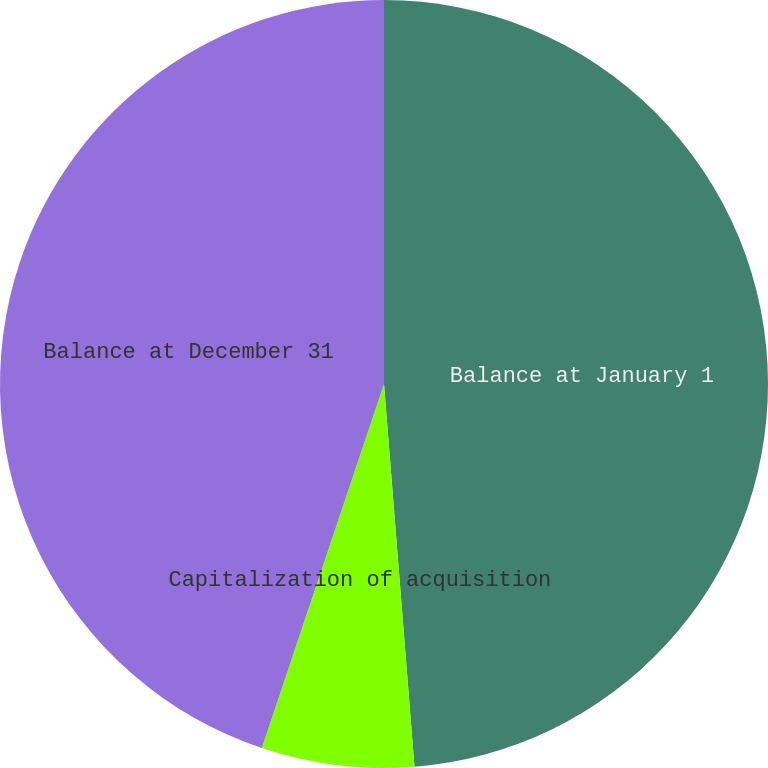<chart> <loc_0><loc_0><loc_500><loc_500><pie_chart><fcel>Balance at January 1<fcel>Capitalization of acquisition<fcel>Balance at December 31<nl><fcel>48.74%<fcel>6.42%<fcel>44.85%<nl></chart> 